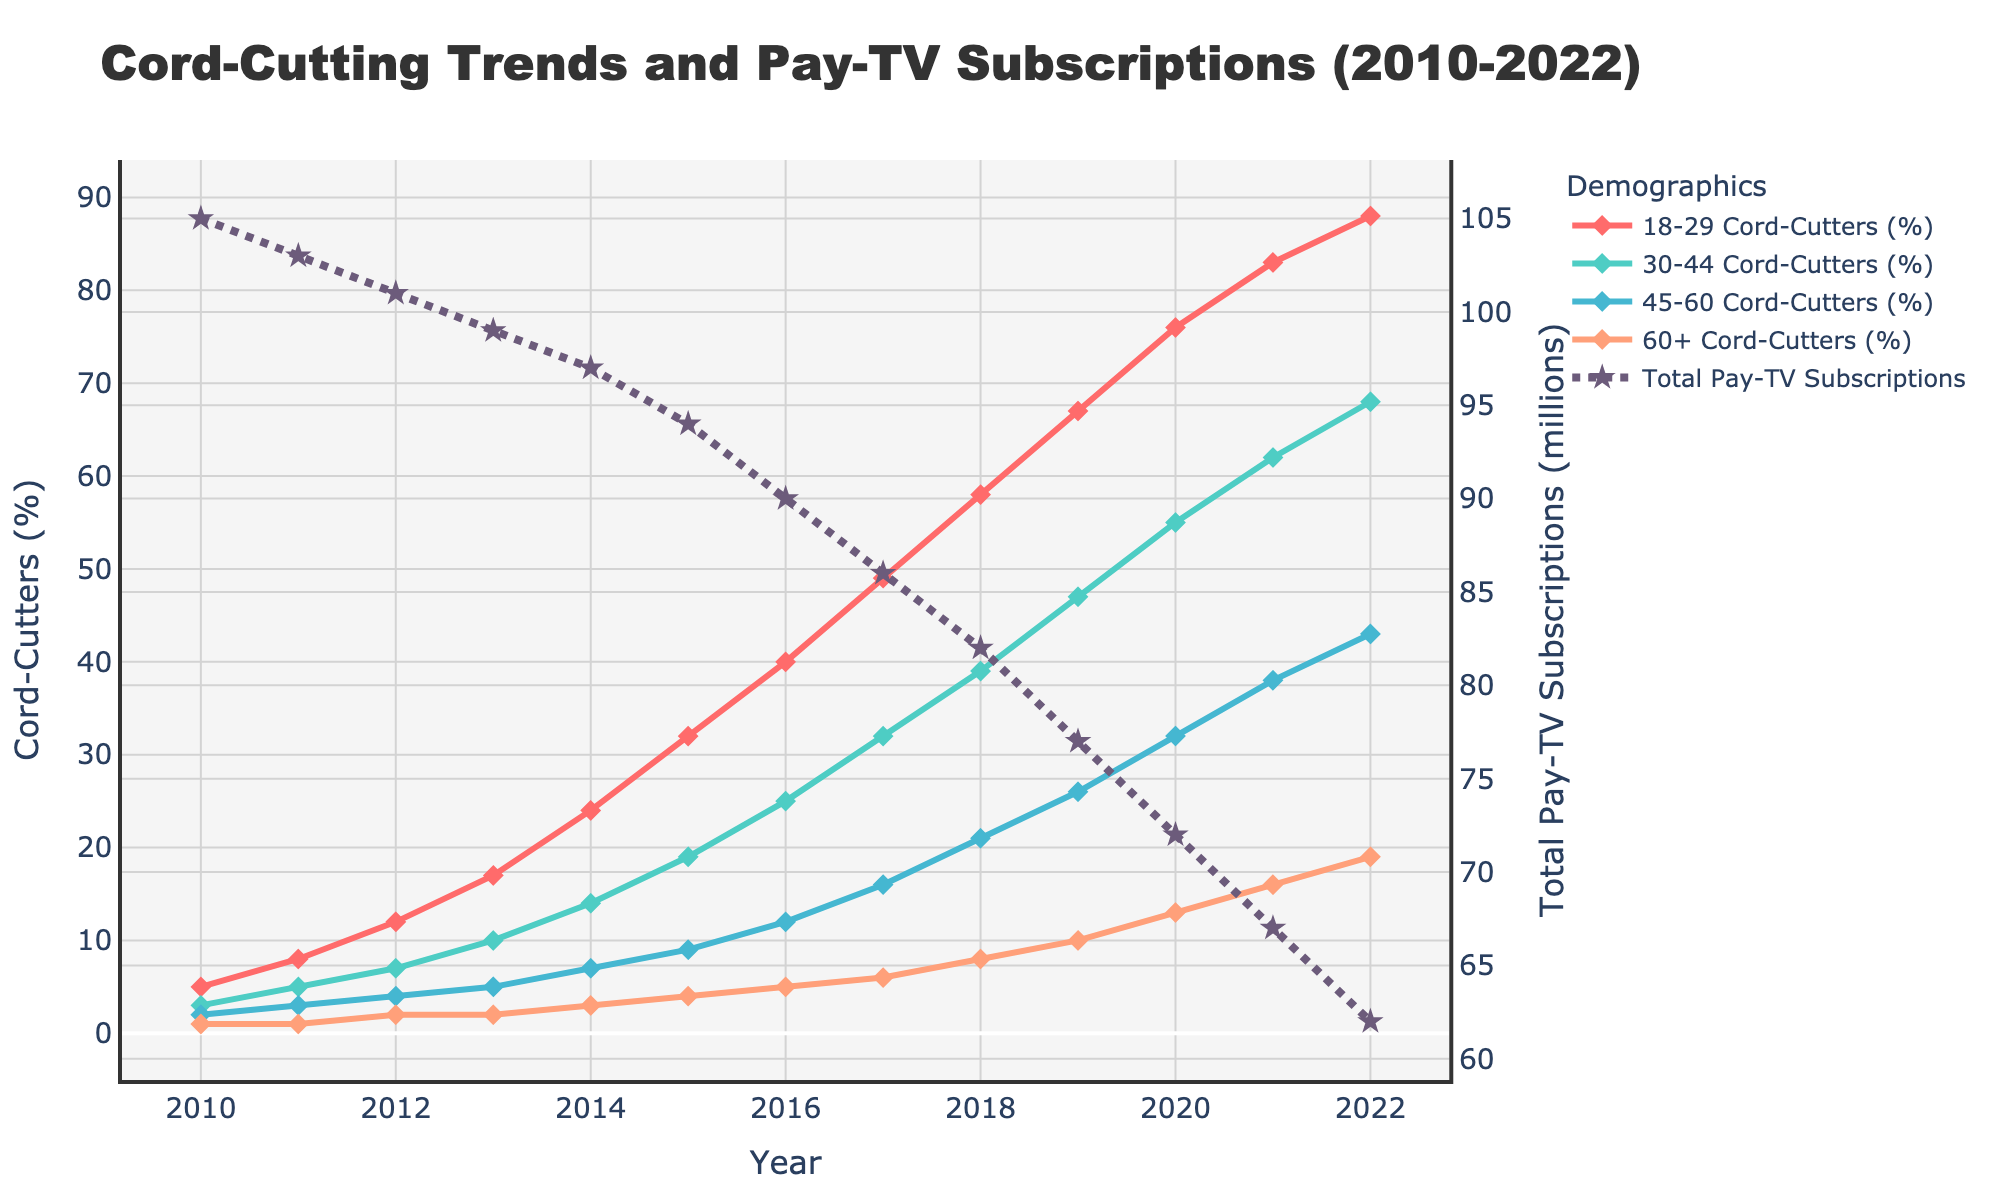What percentage of 18-29 cord-cutters was recorded in 2022? Looking at the figure, the data point for 18-29 cord-cutters in 2022 is at 88%.
Answer: 88% How does the cord-cutting trend for the 30-44 age group compare to the 18-29 age group in 2022? The figure shows that by 2022, 30-44 cord-cutters reached 68%, while 18-29 cord-cutters were at 88%. Thus, the 18-29 age group has a higher percentage of cord-cutters.
Answer: 18-29 has a higher percentage Which age group had the smallest increase in cord-cutting percentage from 2010 to 2022? Find the initial and final cord-cutting percentages for all age groups, then calculate the increase for each:
- 18-29: 88% - 5% = 83%
- 30-44: 68% - 3% = 65%
- 45-60: 43% - 2% = 41%
- 60+: 19% - 1% = 18%
The 60+ age group had the smallest increase.
Answer: 60+ What is the overall trend in total pay-TV subscriptions from 2010 to 2022? The figure shows a steady decline in total pay-TV subscriptions from 105 million in 2010 to 62 million in 2022.
Answer: Declining By what percentage did cord-cutting grow in the 45-60 age group between 2015 and 2020? The data points show that the percentage of cord-cutters in the 45-60 age group in 2015 was 9% and in 2020 it was 32%. The increase is calculated as: (32% - 9%) / 9% * 100 = 255.6%.
Answer: 255.6% What was the difference in cord-cutting percentages between the 18-29 and 60+ age groups in 2010? In 2010, the 18-29 group had 5% cord-cutters, and the 60+ group had 1%. The difference is 5% - 1% = 4%.
Answer: 4% How much did the total pay-TV subscriptions drop from 2017 to 2022? The data points show that total pay-TV subscriptions in 2017 were 86 million, and in 2022 they were 62 million. The drop is 86 million - 62 million = 24 million.
Answer: 24 million Which age group had the highest percentage of cord-cutters in 2020? The figure shows notable peaks in 2020. The 18-29 group had the highest cord-cutting percentage at 76%.
Answer: 18-29 What is the average cord-cutting percentage for the 30-44 age group from 2010 to 2022? Summing the percentages for the 30-44 age group from 2010 to 2022 and dividing by the number of data points:
(3% + 5% + 7% + 10% + 14% + 19% + 25% + 32% + 39% + 47% + 55% + 62% + 68%) / 13 ≈ 30.3%.
Answer: 30.3% 